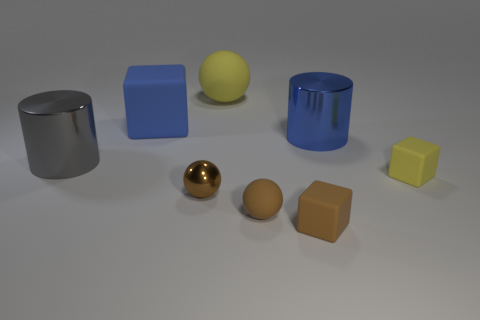Add 1 brown rubber blocks. How many objects exist? 9 Subtract all cylinders. How many objects are left? 6 Add 4 matte things. How many matte things exist? 9 Subtract 0 red cubes. How many objects are left? 8 Subtract all blue cubes. Subtract all tiny balls. How many objects are left? 5 Add 6 yellow cubes. How many yellow cubes are left? 7 